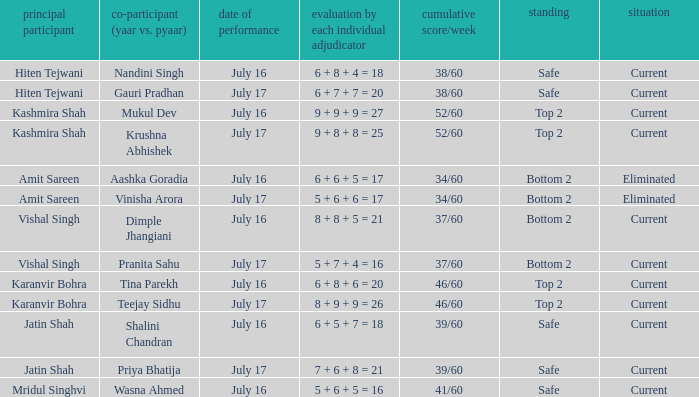What position did the team with the total score of 41/60 get? Safe. 